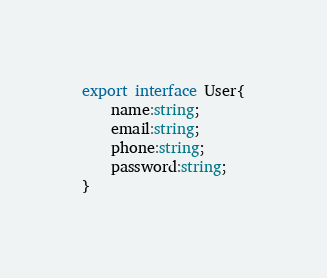Convert code to text. <code><loc_0><loc_0><loc_500><loc_500><_TypeScript_>export interface User{
    name:string;
    email:string;
    phone:string;
    password:string;
}</code> 